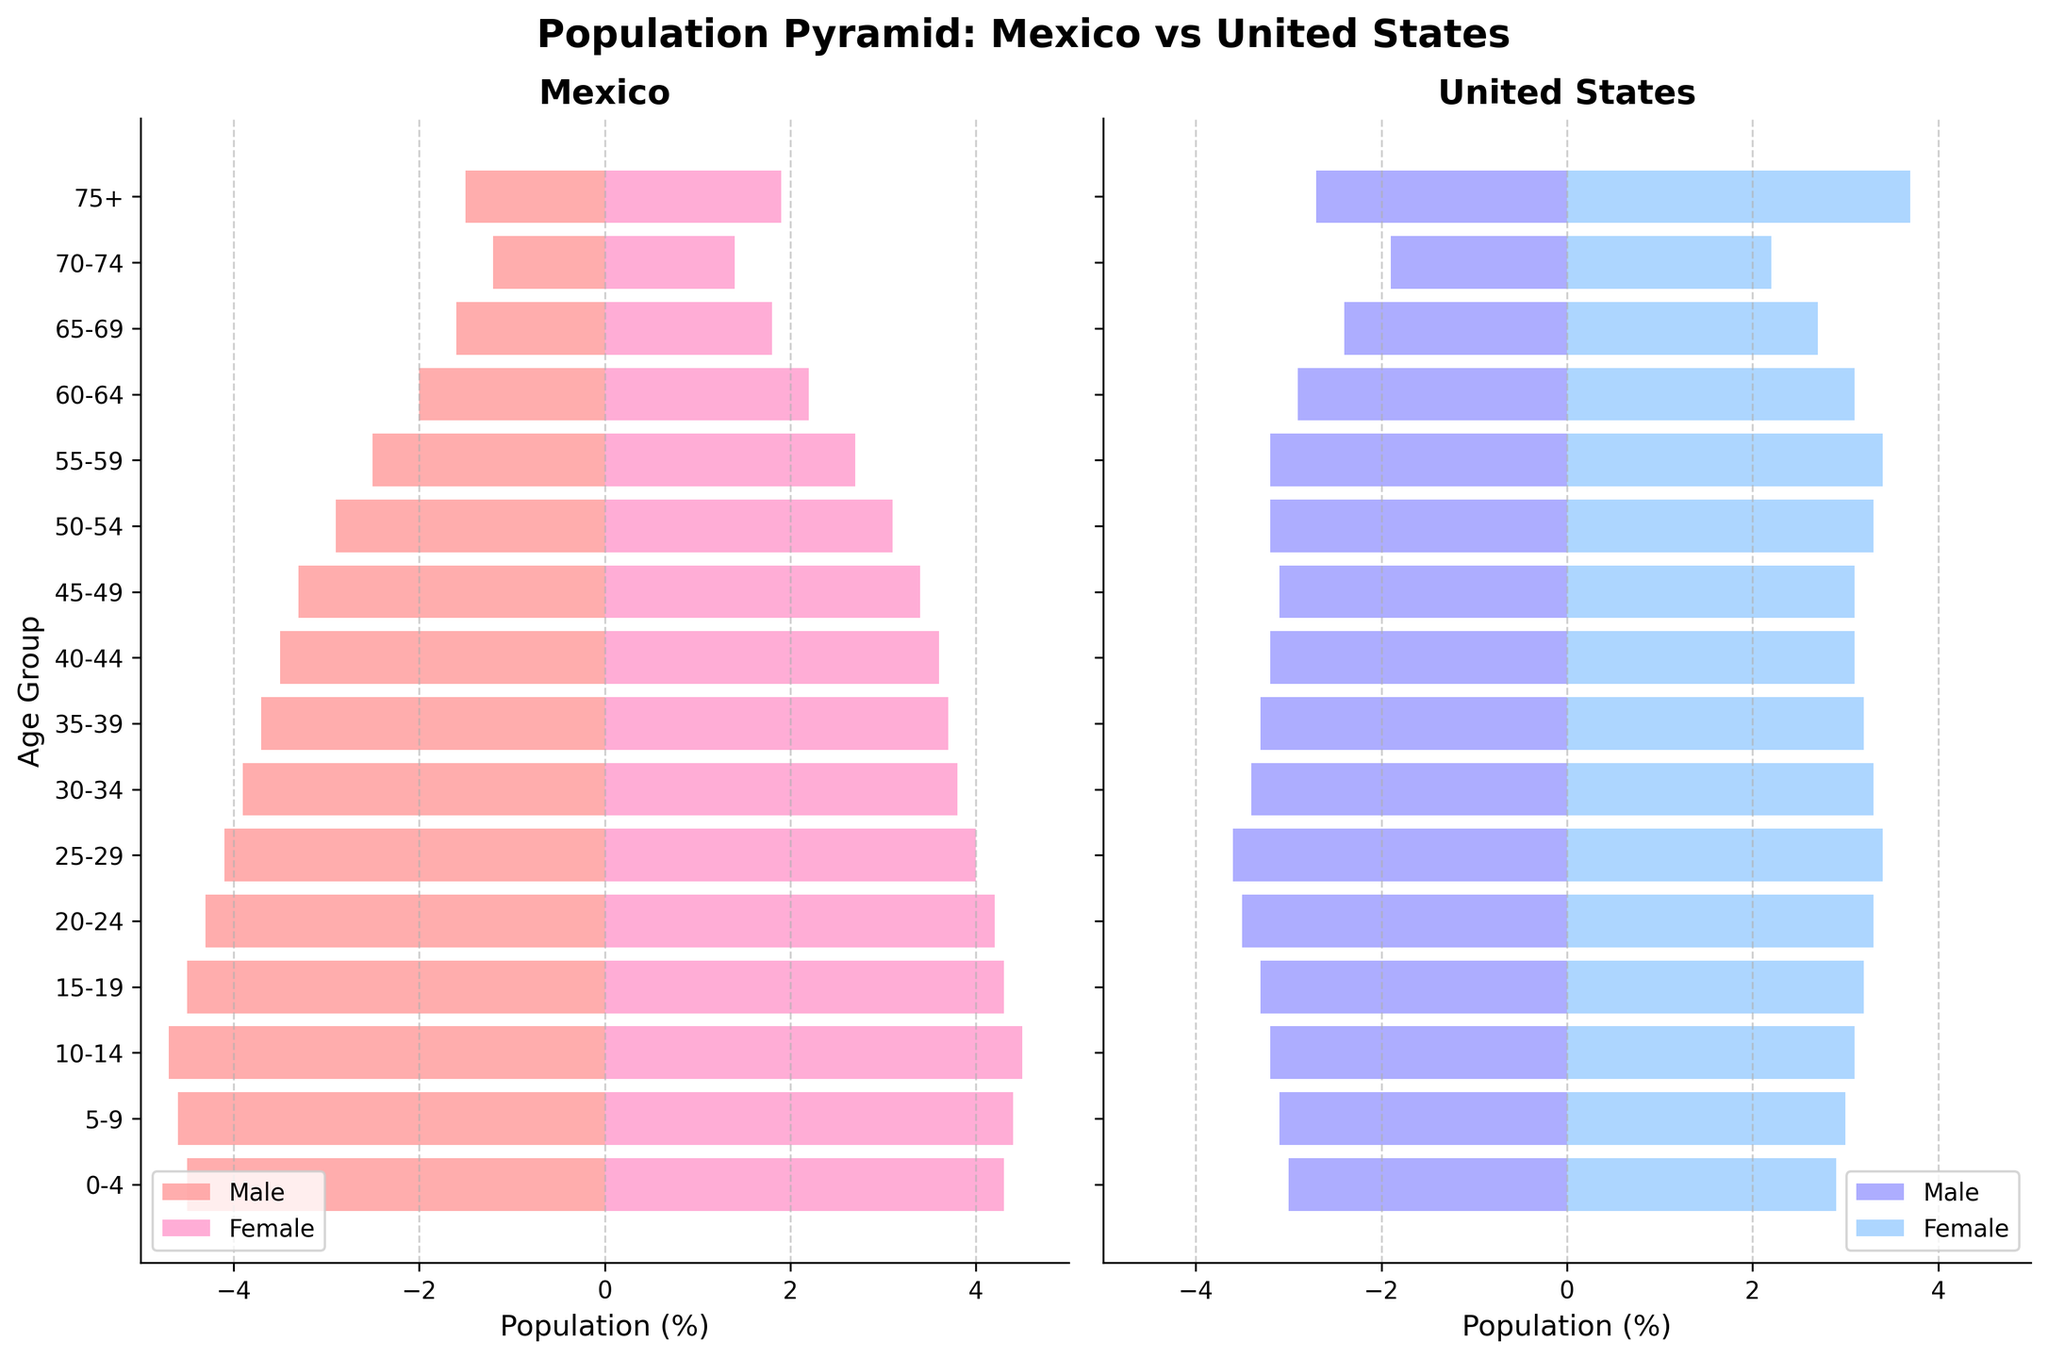What are the titles of the two halves of the population pyramid? The titles of the two halves are shown at the top of each bar chart in the population pyramid. On the left, it is labeled "Mexico," and on the right, it is labeled "United States."
Answer: Mexico and United States Which age group in Mexico has the largest male population percentage? By looking at the left side's bars for Mexico in the population pyramid, the longest bar for males is found in the "10-14" age group.
Answer: 10-14 How does the female population percentage of the "75+" age group in the United States compare to Mexico? The female population percentage bar for the "75+" age group is longer on the United States side compared to the Mexico side, indicating the percentage is higher.
Answer: Higher in the United States What is the approximate difference in population percentage for females in the "30-34" age group between Mexico and the United States? Looking at the bars for females in the "30-34" age group in both Mexico and the United States, the difference is about 0.5% with Mexico having about 3.8% and the United States having about 3.3%.
Answer: Approximately 0.5% Which country has a larger proportion of its population in the "0-4" age group? The bars on the population pyramid show that both males and females in the "0-4" age group are larger in Mexico than in the United States.
Answer: Mexico What trend can be observed regarding the population percentage of older age groups (e.g., "65+") in the United States compared to Mexico? Observing the bars for age groups "65+" in both countries, the United States shows a higher percentage for older populations compared to Mexico.
Answer: Higher in the United States Which gender has a higher population percentage in the "55-59" age group in Mexico? Comparing the lengths of the male and female bars for the "55-59" age group in Mexico, the female bar is longer, indicating that females have a higher population percentage.
Answer: Female For the age group "40-44", which gender has a higher population percentage in the United States? In the "40-44" age group on the United States side, the male and female bars are compared. The male bar is slightly shorter than the female bar, indicating females have a higher population percentage.
Answer: Female How does the population percentage of the "20-24" age group for males in Mexico compare to the "20-24" age group for males in the United States? The population percentage for males in the "20-24" age group in Mexico is shown by the length of the bar compared to the similar bar in the United States. Mexico has a longer bar, indicating a higher percentage.
Answer: Higher in Mexico What can you infer about the overall age structure of the population in Mexico compared to the United States? The pyramidal shape of Mexico's bars indicates a younger population with higher percentages in the younger age groups and tapering off more rapidly with age. In contrast, the United States has a more rectangular shape with relatively even distribution across many age groups, indicating an older average population.
Answer: Mexico has a younger population structure 